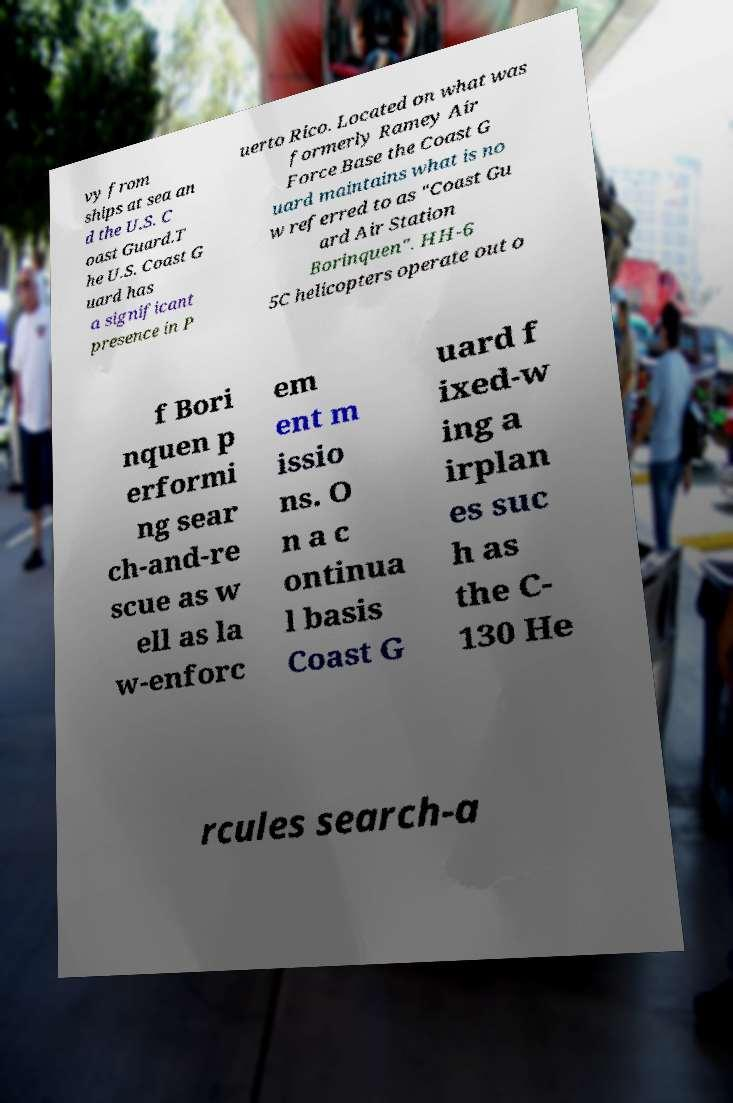Please identify and transcribe the text found in this image. vy from ships at sea an d the U.S. C oast Guard.T he U.S. Coast G uard has a significant presence in P uerto Rico. Located on what was formerly Ramey Air Force Base the Coast G uard maintains what is no w referred to as "Coast Gu ard Air Station Borinquen". HH-6 5C helicopters operate out o f Bori nquen p erformi ng sear ch-and-re scue as w ell as la w-enforc em ent m issio ns. O n a c ontinua l basis Coast G uard f ixed-w ing a irplan es suc h as the C- 130 He rcules search-a 